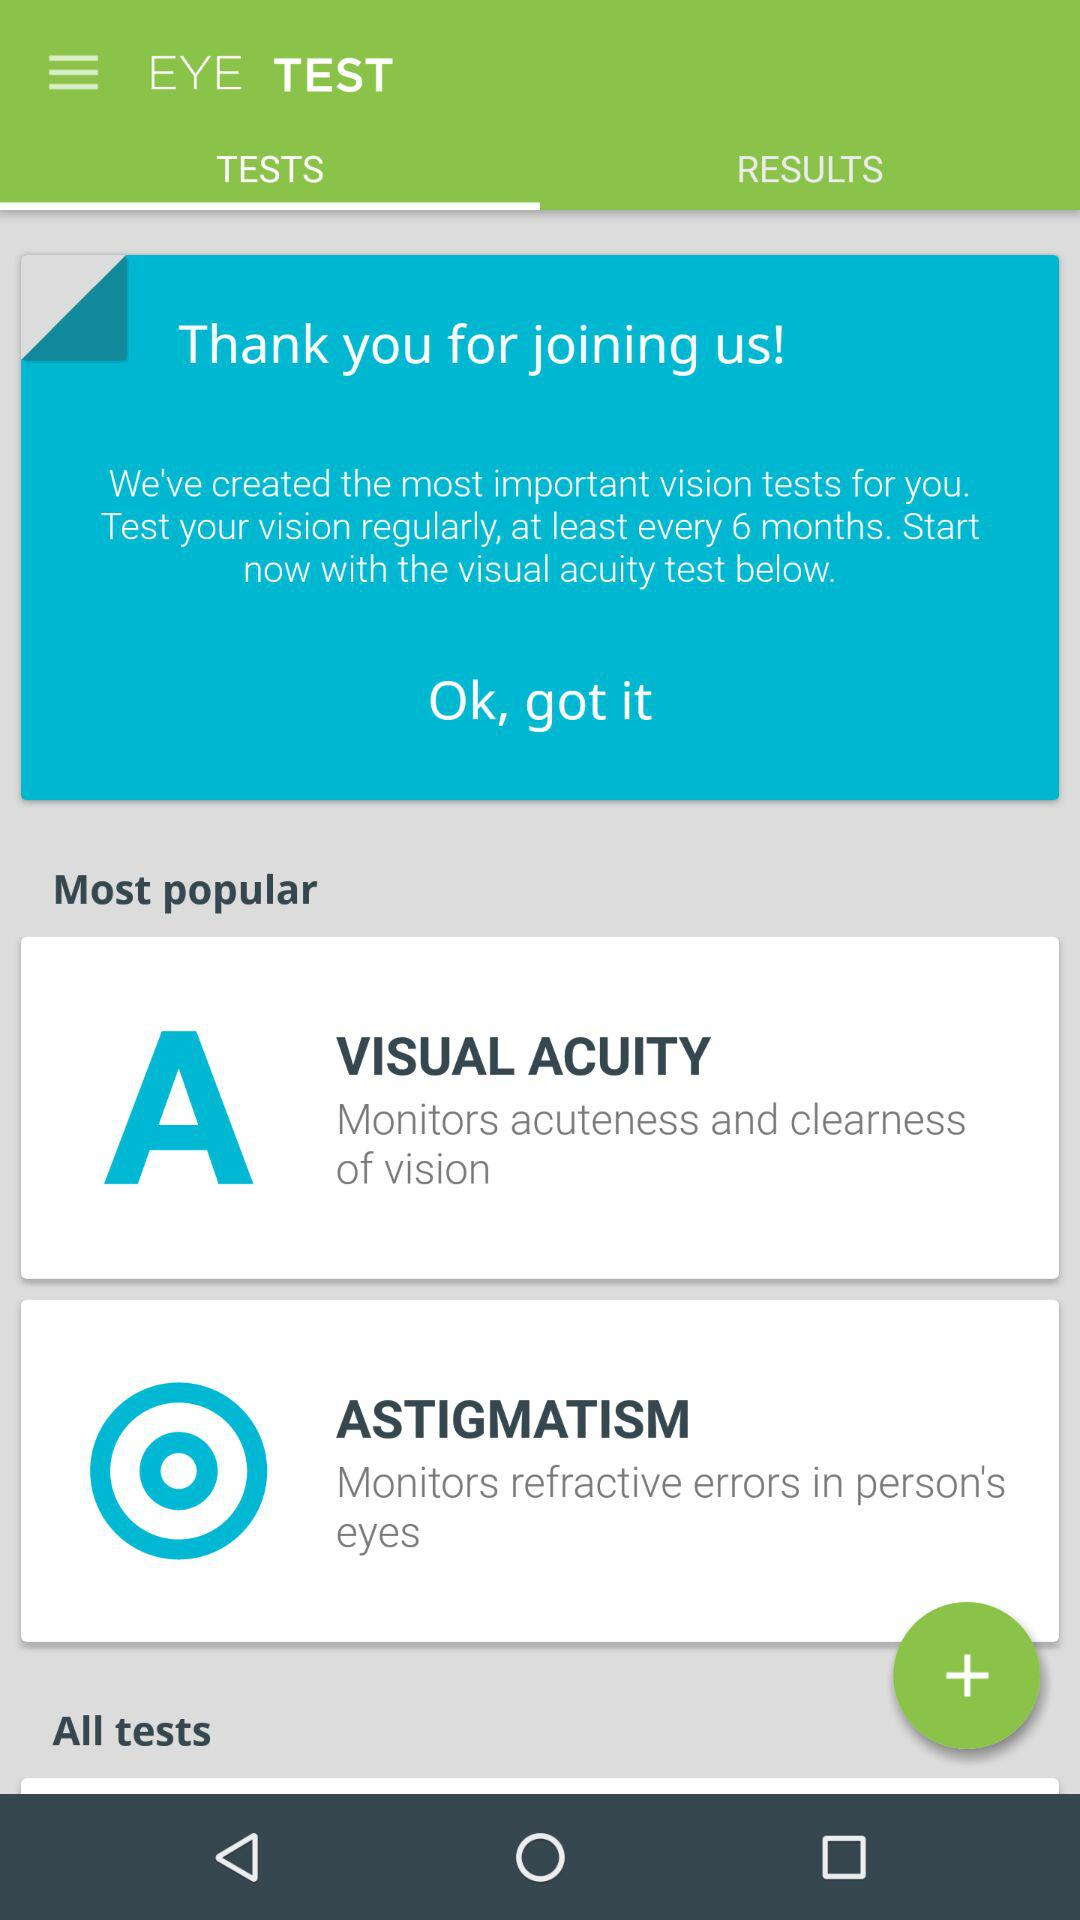How many tests are there in total?
Answer the question using a single word or phrase. 2 